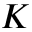Convert formula to latex. <formula><loc_0><loc_0><loc_500><loc_500>K</formula> 